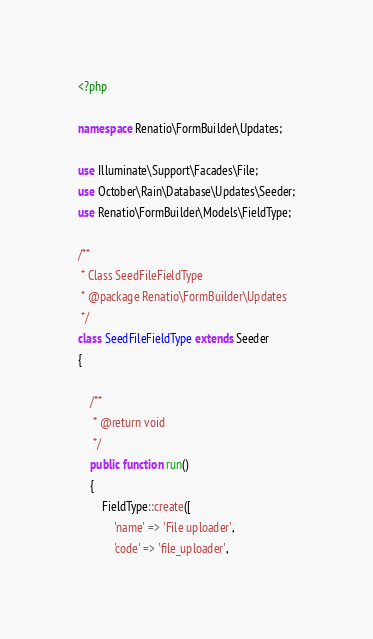<code> <loc_0><loc_0><loc_500><loc_500><_PHP_><?php

namespace Renatio\FormBuilder\Updates;

use Illuminate\Support\Facades\File;
use October\Rain\Database\Updates\Seeder;
use Renatio\FormBuilder\Models\FieldType;

/**
 * Class SeedFileFieldType
 * @package Renatio\FormBuilder\Updates
 */
class SeedFileFieldType extends Seeder
{

    /**
     * @return void
     */
    public function run()
    {
        FieldType::create([
            'name' => 'File uploader',
            'code' => 'file_uploader',</code> 